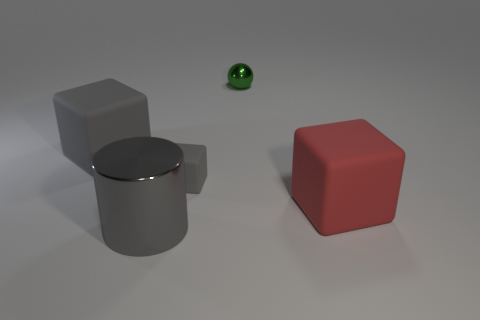Add 1 big yellow spheres. How many objects exist? 6 Subtract all cylinders. How many objects are left? 4 Subtract all big gray blocks. Subtract all big gray metal cylinders. How many objects are left? 3 Add 4 large red objects. How many large red objects are left? 5 Add 1 large metal cylinders. How many large metal cylinders exist? 2 Subtract 0 brown balls. How many objects are left? 5 